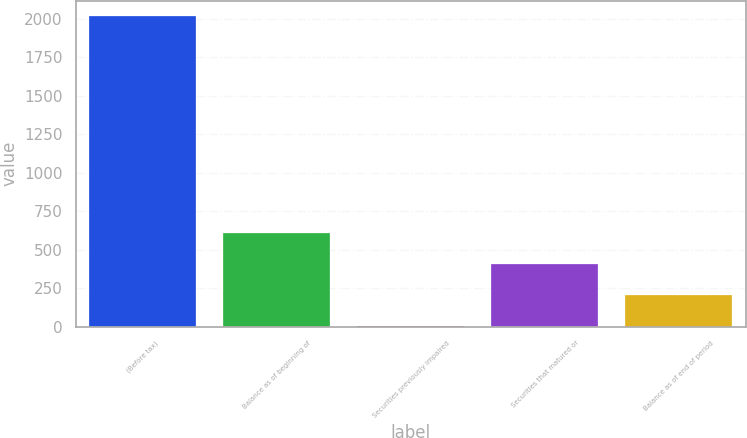Convert chart to OTSL. <chart><loc_0><loc_0><loc_500><loc_500><bar_chart><fcel>(Before tax)<fcel>Balance as of beginning of<fcel>Securities previously impaired<fcel>Securities that matured or<fcel>Balance as of end of period<nl><fcel>2017<fcel>605.8<fcel>1<fcel>404.2<fcel>202.6<nl></chart> 